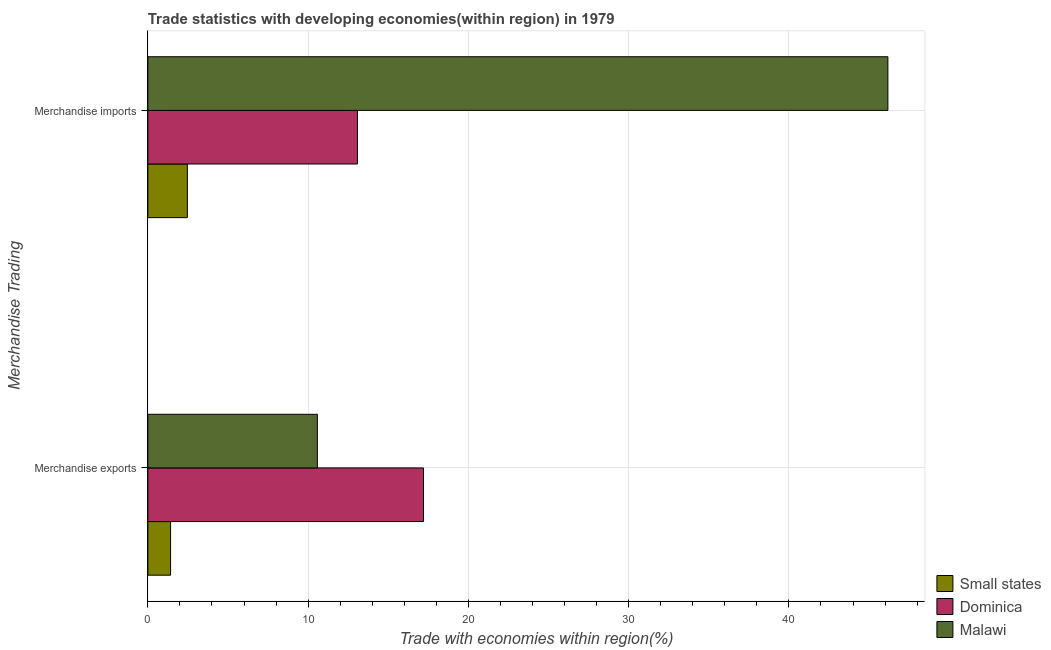How many different coloured bars are there?
Make the answer very short. 3. How many groups of bars are there?
Give a very brief answer. 2. Are the number of bars per tick equal to the number of legend labels?
Your answer should be very brief. Yes. Are the number of bars on each tick of the Y-axis equal?
Keep it short and to the point. Yes. How many bars are there on the 2nd tick from the bottom?
Make the answer very short. 3. What is the label of the 1st group of bars from the top?
Offer a very short reply. Merchandise imports. What is the merchandise imports in Dominica?
Provide a succinct answer. 13.08. Across all countries, what is the maximum merchandise exports?
Provide a succinct answer. 17.2. Across all countries, what is the minimum merchandise imports?
Ensure brevity in your answer.  2.46. In which country was the merchandise exports maximum?
Keep it short and to the point. Dominica. In which country was the merchandise exports minimum?
Make the answer very short. Small states. What is the total merchandise exports in the graph?
Your response must be concise. 29.19. What is the difference between the merchandise exports in Dominica and that in Malawi?
Provide a succinct answer. 6.62. What is the difference between the merchandise imports in Dominica and the merchandise exports in Small states?
Keep it short and to the point. 11.66. What is the average merchandise exports per country?
Your answer should be very brief. 9.73. What is the difference between the merchandise imports and merchandise exports in Small states?
Give a very brief answer. 1.05. In how many countries, is the merchandise exports greater than 24 %?
Provide a succinct answer. 0. What is the ratio of the merchandise imports in Small states to that in Dominica?
Keep it short and to the point. 0.19. Is the merchandise imports in Small states less than that in Dominica?
Ensure brevity in your answer.  Yes. In how many countries, is the merchandise exports greater than the average merchandise exports taken over all countries?
Provide a succinct answer. 2. What does the 2nd bar from the top in Merchandise exports represents?
Your answer should be compact. Dominica. What does the 1st bar from the bottom in Merchandise exports represents?
Offer a very short reply. Small states. Are all the bars in the graph horizontal?
Keep it short and to the point. Yes. How many countries are there in the graph?
Provide a short and direct response. 3. Where does the legend appear in the graph?
Offer a very short reply. Bottom right. What is the title of the graph?
Your answer should be compact. Trade statistics with developing economies(within region) in 1979. Does "Niger" appear as one of the legend labels in the graph?
Your answer should be very brief. No. What is the label or title of the X-axis?
Provide a succinct answer. Trade with economies within region(%). What is the label or title of the Y-axis?
Your answer should be very brief. Merchandise Trading. What is the Trade with economies within region(%) in Small states in Merchandise exports?
Offer a terse response. 1.42. What is the Trade with economies within region(%) in Dominica in Merchandise exports?
Your answer should be compact. 17.2. What is the Trade with economies within region(%) of Malawi in Merchandise exports?
Offer a very short reply. 10.58. What is the Trade with economies within region(%) of Small states in Merchandise imports?
Your answer should be very brief. 2.46. What is the Trade with economies within region(%) of Dominica in Merchandise imports?
Give a very brief answer. 13.08. What is the Trade with economies within region(%) of Malawi in Merchandise imports?
Ensure brevity in your answer.  46.18. Across all Merchandise Trading, what is the maximum Trade with economies within region(%) of Small states?
Offer a terse response. 2.46. Across all Merchandise Trading, what is the maximum Trade with economies within region(%) in Dominica?
Your answer should be compact. 17.2. Across all Merchandise Trading, what is the maximum Trade with economies within region(%) of Malawi?
Your answer should be compact. 46.18. Across all Merchandise Trading, what is the minimum Trade with economies within region(%) of Small states?
Your answer should be very brief. 1.42. Across all Merchandise Trading, what is the minimum Trade with economies within region(%) in Dominica?
Your answer should be compact. 13.08. Across all Merchandise Trading, what is the minimum Trade with economies within region(%) of Malawi?
Provide a short and direct response. 10.58. What is the total Trade with economies within region(%) of Small states in the graph?
Your response must be concise. 3.88. What is the total Trade with economies within region(%) of Dominica in the graph?
Make the answer very short. 30.28. What is the total Trade with economies within region(%) in Malawi in the graph?
Make the answer very short. 56.76. What is the difference between the Trade with economies within region(%) in Small states in Merchandise exports and that in Merchandise imports?
Give a very brief answer. -1.05. What is the difference between the Trade with economies within region(%) in Dominica in Merchandise exports and that in Merchandise imports?
Make the answer very short. 4.12. What is the difference between the Trade with economies within region(%) in Malawi in Merchandise exports and that in Merchandise imports?
Offer a terse response. -35.6. What is the difference between the Trade with economies within region(%) in Small states in Merchandise exports and the Trade with economies within region(%) in Dominica in Merchandise imports?
Provide a short and direct response. -11.66. What is the difference between the Trade with economies within region(%) of Small states in Merchandise exports and the Trade with economies within region(%) of Malawi in Merchandise imports?
Your answer should be very brief. -44.76. What is the difference between the Trade with economies within region(%) in Dominica in Merchandise exports and the Trade with economies within region(%) in Malawi in Merchandise imports?
Offer a very short reply. -28.98. What is the average Trade with economies within region(%) of Small states per Merchandise Trading?
Make the answer very short. 1.94. What is the average Trade with economies within region(%) in Dominica per Merchandise Trading?
Offer a terse response. 15.14. What is the average Trade with economies within region(%) in Malawi per Merchandise Trading?
Offer a very short reply. 28.38. What is the difference between the Trade with economies within region(%) of Small states and Trade with economies within region(%) of Dominica in Merchandise exports?
Your answer should be very brief. -15.78. What is the difference between the Trade with economies within region(%) of Small states and Trade with economies within region(%) of Malawi in Merchandise exports?
Keep it short and to the point. -9.16. What is the difference between the Trade with economies within region(%) in Dominica and Trade with economies within region(%) in Malawi in Merchandise exports?
Your answer should be compact. 6.62. What is the difference between the Trade with economies within region(%) in Small states and Trade with economies within region(%) in Dominica in Merchandise imports?
Keep it short and to the point. -10.62. What is the difference between the Trade with economies within region(%) in Small states and Trade with economies within region(%) in Malawi in Merchandise imports?
Give a very brief answer. -43.71. What is the difference between the Trade with economies within region(%) of Dominica and Trade with economies within region(%) of Malawi in Merchandise imports?
Offer a very short reply. -33.1. What is the ratio of the Trade with economies within region(%) in Small states in Merchandise exports to that in Merchandise imports?
Make the answer very short. 0.57. What is the ratio of the Trade with economies within region(%) in Dominica in Merchandise exports to that in Merchandise imports?
Make the answer very short. 1.31. What is the ratio of the Trade with economies within region(%) of Malawi in Merchandise exports to that in Merchandise imports?
Offer a terse response. 0.23. What is the difference between the highest and the second highest Trade with economies within region(%) of Small states?
Your answer should be very brief. 1.05. What is the difference between the highest and the second highest Trade with economies within region(%) of Dominica?
Your response must be concise. 4.12. What is the difference between the highest and the second highest Trade with economies within region(%) of Malawi?
Your answer should be compact. 35.6. What is the difference between the highest and the lowest Trade with economies within region(%) of Small states?
Your answer should be very brief. 1.05. What is the difference between the highest and the lowest Trade with economies within region(%) in Dominica?
Keep it short and to the point. 4.12. What is the difference between the highest and the lowest Trade with economies within region(%) in Malawi?
Offer a very short reply. 35.6. 